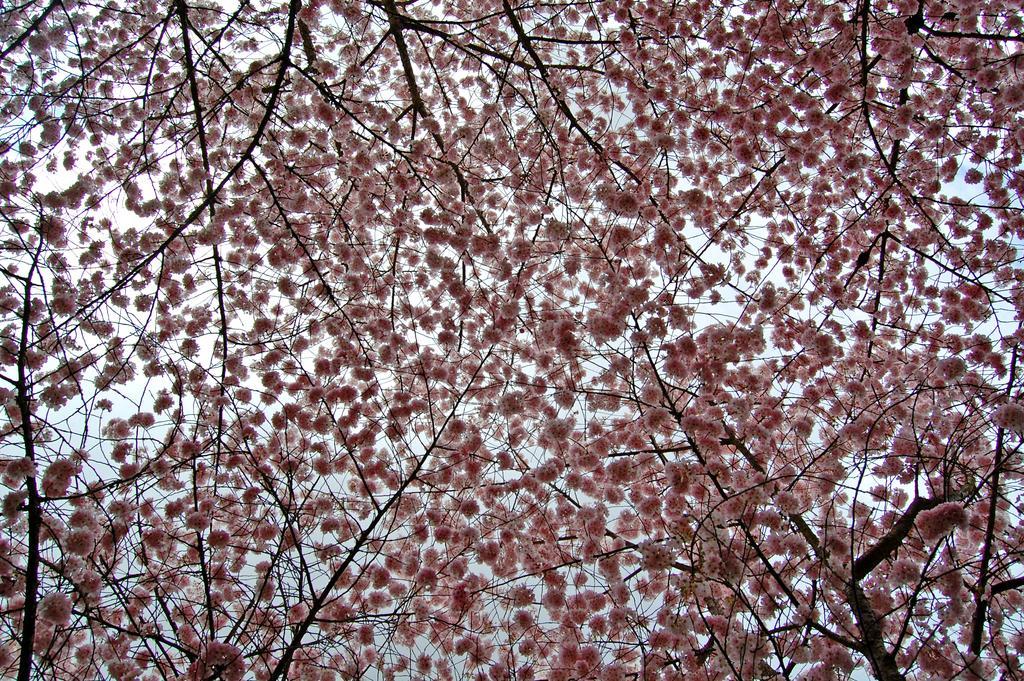How would you summarize this image in a sentence or two? In this image we can see branches with flowers. In the background there is sky. 